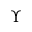Convert formula to latex. <formula><loc_0><loc_0><loc_500><loc_500>\Upsilon</formula> 